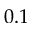Convert formula to latex. <formula><loc_0><loc_0><loc_500><loc_500>0 . 1</formula> 